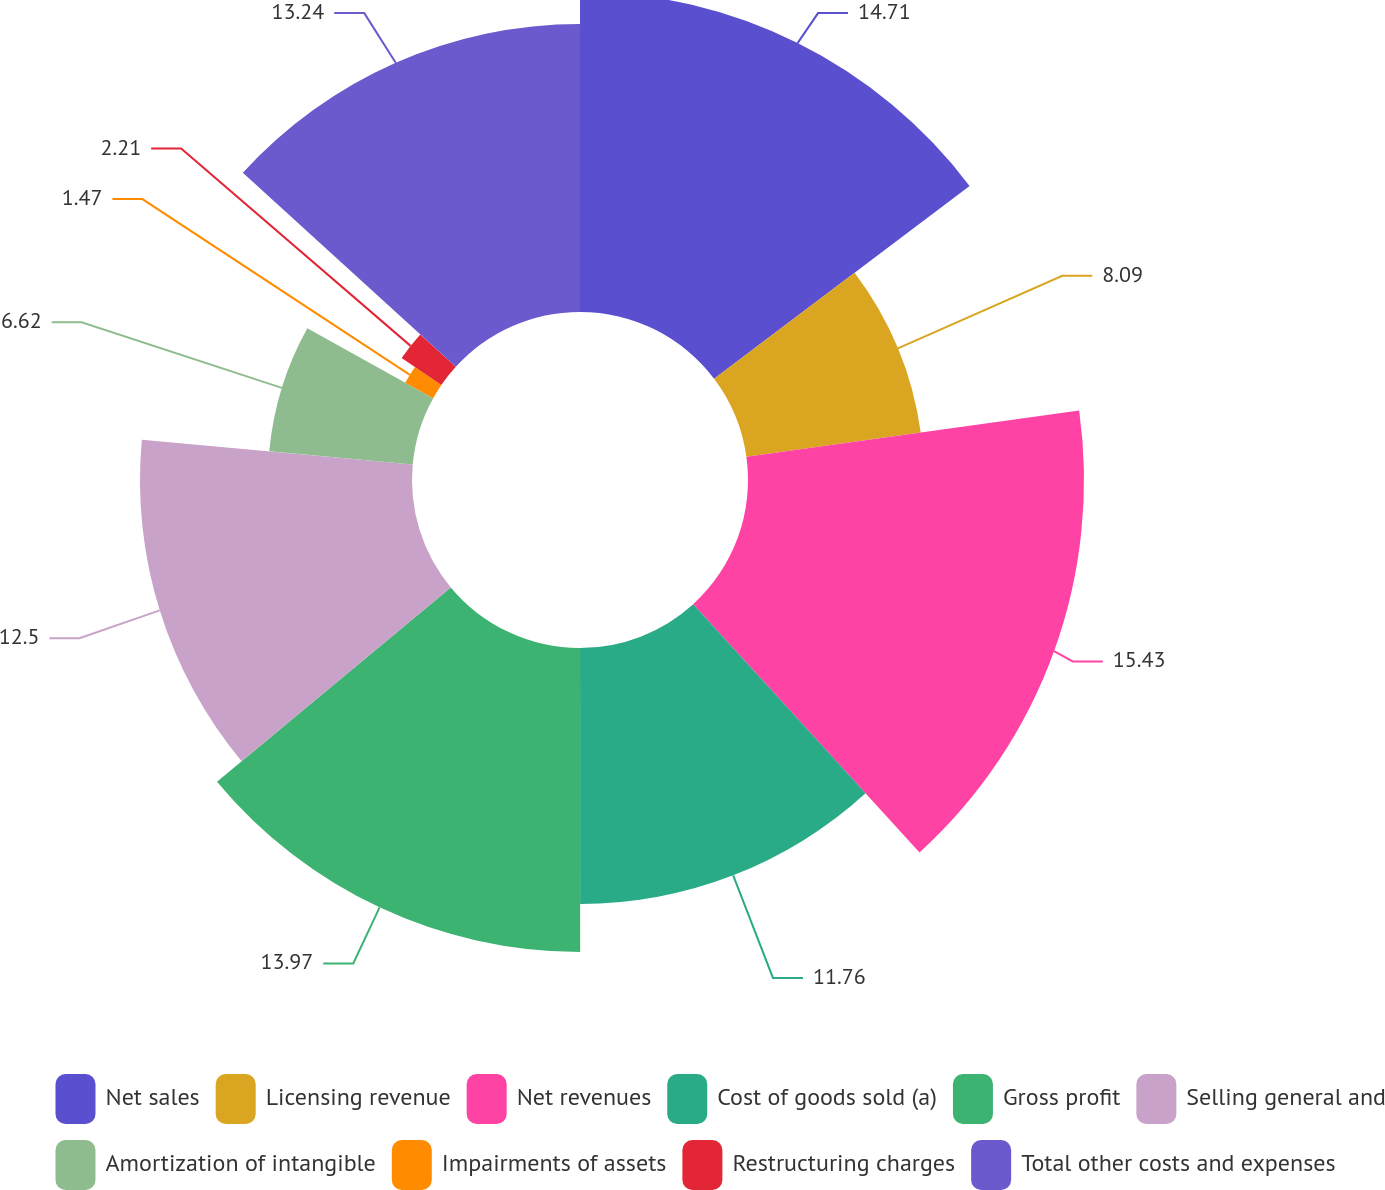Convert chart. <chart><loc_0><loc_0><loc_500><loc_500><pie_chart><fcel>Net sales<fcel>Licensing revenue<fcel>Net revenues<fcel>Cost of goods sold (a)<fcel>Gross profit<fcel>Selling general and<fcel>Amortization of intangible<fcel>Impairments of assets<fcel>Restructuring charges<fcel>Total other costs and expenses<nl><fcel>14.71%<fcel>8.09%<fcel>15.44%<fcel>11.76%<fcel>13.97%<fcel>12.5%<fcel>6.62%<fcel>1.47%<fcel>2.21%<fcel>13.24%<nl></chart> 